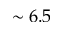<formula> <loc_0><loc_0><loc_500><loc_500>\sim 6 . 5</formula> 